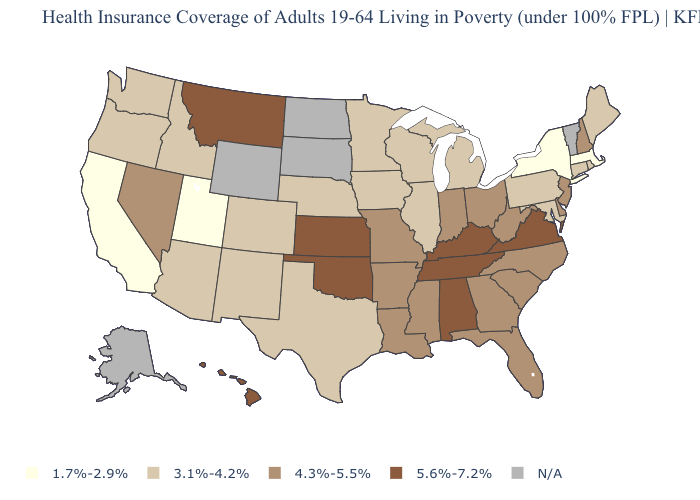Does New York have the lowest value in the USA?
Short answer required. Yes. What is the lowest value in the West?
Keep it brief. 1.7%-2.9%. Is the legend a continuous bar?
Concise answer only. No. Name the states that have a value in the range 3.1%-4.2%?
Concise answer only. Arizona, Colorado, Connecticut, Idaho, Illinois, Iowa, Maine, Maryland, Michigan, Minnesota, Nebraska, New Mexico, Oregon, Pennsylvania, Rhode Island, Texas, Washington, Wisconsin. Name the states that have a value in the range 1.7%-2.9%?
Write a very short answer. California, Massachusetts, New York, Utah. Name the states that have a value in the range 4.3%-5.5%?
Be succinct. Arkansas, Delaware, Florida, Georgia, Indiana, Louisiana, Mississippi, Missouri, Nevada, New Hampshire, New Jersey, North Carolina, Ohio, South Carolina, West Virginia. Name the states that have a value in the range 1.7%-2.9%?
Write a very short answer. California, Massachusetts, New York, Utah. Name the states that have a value in the range 4.3%-5.5%?
Give a very brief answer. Arkansas, Delaware, Florida, Georgia, Indiana, Louisiana, Mississippi, Missouri, Nevada, New Hampshire, New Jersey, North Carolina, Ohio, South Carolina, West Virginia. Name the states that have a value in the range 3.1%-4.2%?
Short answer required. Arizona, Colorado, Connecticut, Idaho, Illinois, Iowa, Maine, Maryland, Michigan, Minnesota, Nebraska, New Mexico, Oregon, Pennsylvania, Rhode Island, Texas, Washington, Wisconsin. Name the states that have a value in the range N/A?
Answer briefly. Alaska, North Dakota, South Dakota, Vermont, Wyoming. What is the value of Arizona?
Give a very brief answer. 3.1%-4.2%. Name the states that have a value in the range 1.7%-2.9%?
Write a very short answer. California, Massachusetts, New York, Utah. Does Massachusetts have the lowest value in the USA?
Give a very brief answer. Yes. Which states have the highest value in the USA?
Give a very brief answer. Alabama, Hawaii, Kansas, Kentucky, Montana, Oklahoma, Tennessee, Virginia. 